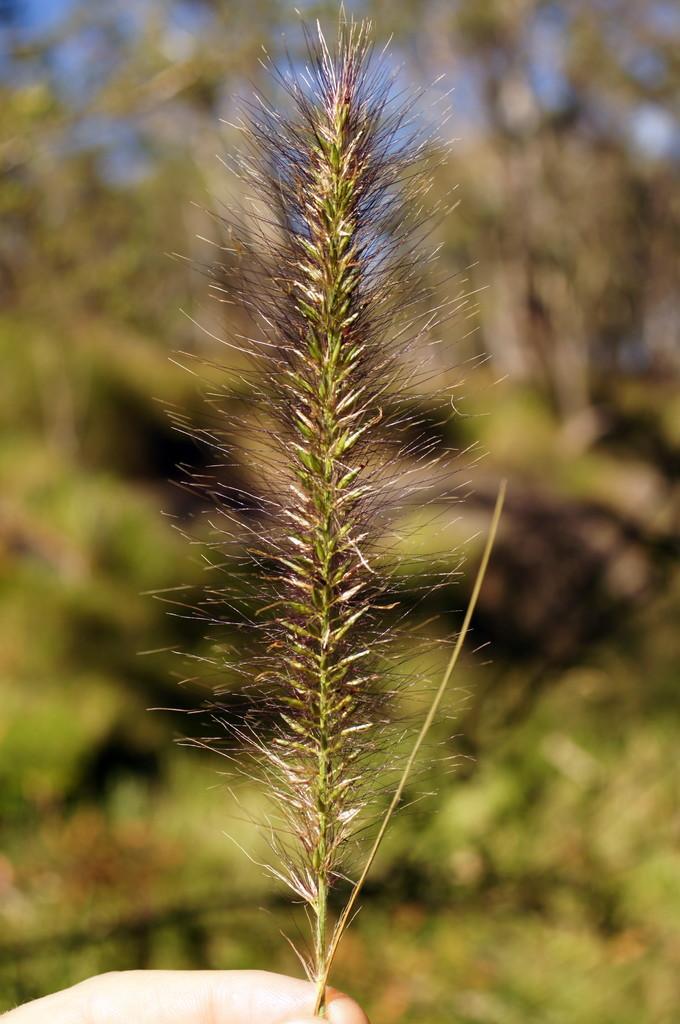Can you describe this image briefly? In this picture, we see a leaf in the human hand and few trees on the back. 